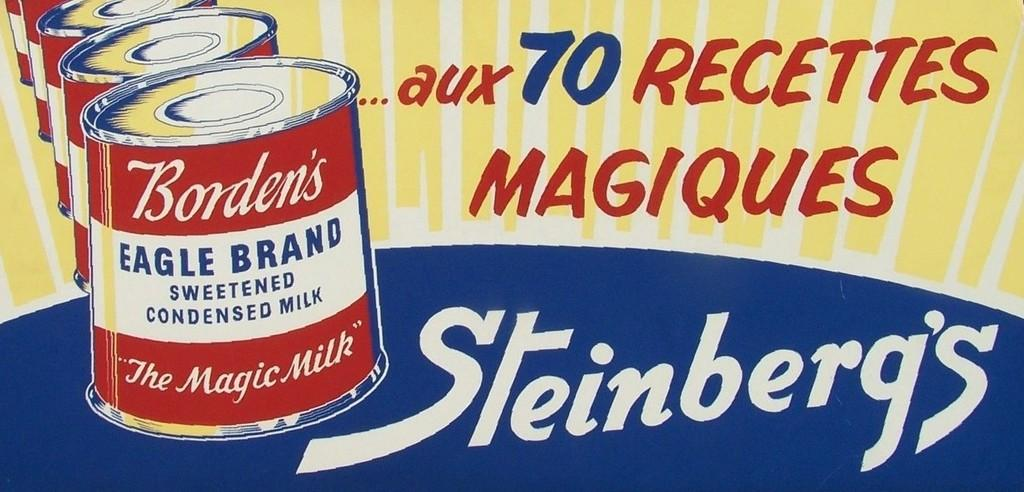<image>
Render a clear and concise summary of the photo. An old-style advertisement for Borden's Eagle Brand Condensed Milk. 